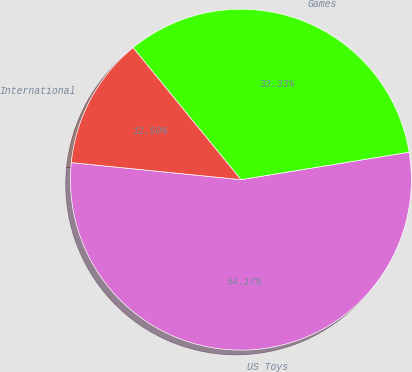Convert chart to OTSL. <chart><loc_0><loc_0><loc_500><loc_500><pie_chart><fcel>US Toys<fcel>Games<fcel>International<nl><fcel>54.17%<fcel>33.33%<fcel>12.5%<nl></chart> 